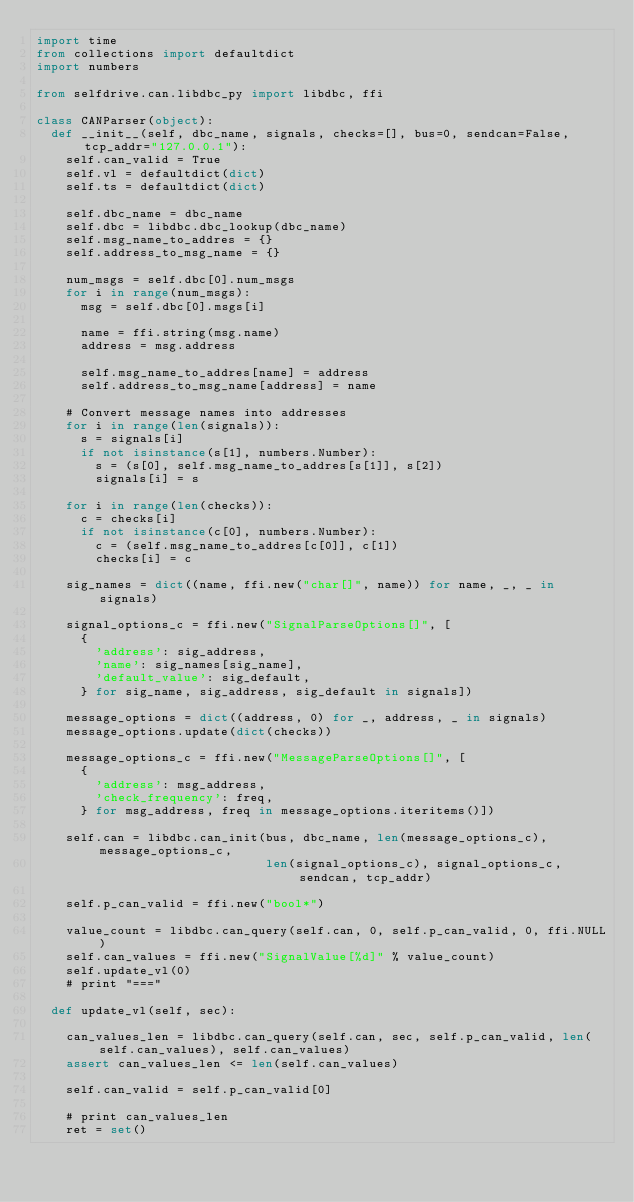Convert code to text. <code><loc_0><loc_0><loc_500><loc_500><_Python_>import time
from collections import defaultdict
import numbers

from selfdrive.can.libdbc_py import libdbc, ffi

class CANParser(object):
  def __init__(self, dbc_name, signals, checks=[], bus=0, sendcan=False, tcp_addr="127.0.0.1"):
    self.can_valid = True
    self.vl = defaultdict(dict)
    self.ts = defaultdict(dict)

    self.dbc_name = dbc_name
    self.dbc = libdbc.dbc_lookup(dbc_name)
    self.msg_name_to_addres = {}
    self.address_to_msg_name = {}

    num_msgs = self.dbc[0].num_msgs
    for i in range(num_msgs):
      msg = self.dbc[0].msgs[i]

      name = ffi.string(msg.name)
      address = msg.address

      self.msg_name_to_addres[name] = address
      self.address_to_msg_name[address] = name

    # Convert message names into addresses
    for i in range(len(signals)):
      s = signals[i]
      if not isinstance(s[1], numbers.Number):
        s = (s[0], self.msg_name_to_addres[s[1]], s[2])
        signals[i] = s

    for i in range(len(checks)):
      c = checks[i]
      if not isinstance(c[0], numbers.Number):
        c = (self.msg_name_to_addres[c[0]], c[1])
        checks[i] = c

    sig_names = dict((name, ffi.new("char[]", name)) for name, _, _ in signals)

    signal_options_c = ffi.new("SignalParseOptions[]", [
      {
        'address': sig_address,
        'name': sig_names[sig_name],
        'default_value': sig_default,
      } for sig_name, sig_address, sig_default in signals])

    message_options = dict((address, 0) for _, address, _ in signals)
    message_options.update(dict(checks))

    message_options_c = ffi.new("MessageParseOptions[]", [
      {
        'address': msg_address,
        'check_frequency': freq,
      } for msg_address, freq in message_options.iteritems()])

    self.can = libdbc.can_init(bus, dbc_name, len(message_options_c), message_options_c,
                               len(signal_options_c), signal_options_c, sendcan, tcp_addr)

    self.p_can_valid = ffi.new("bool*")

    value_count = libdbc.can_query(self.can, 0, self.p_can_valid, 0, ffi.NULL)
    self.can_values = ffi.new("SignalValue[%d]" % value_count)
    self.update_vl(0)
    # print "==="

  def update_vl(self, sec):

    can_values_len = libdbc.can_query(self.can, sec, self.p_can_valid, len(self.can_values), self.can_values)
    assert can_values_len <= len(self.can_values)

    self.can_valid = self.p_can_valid[0]

    # print can_values_len
    ret = set()</code> 